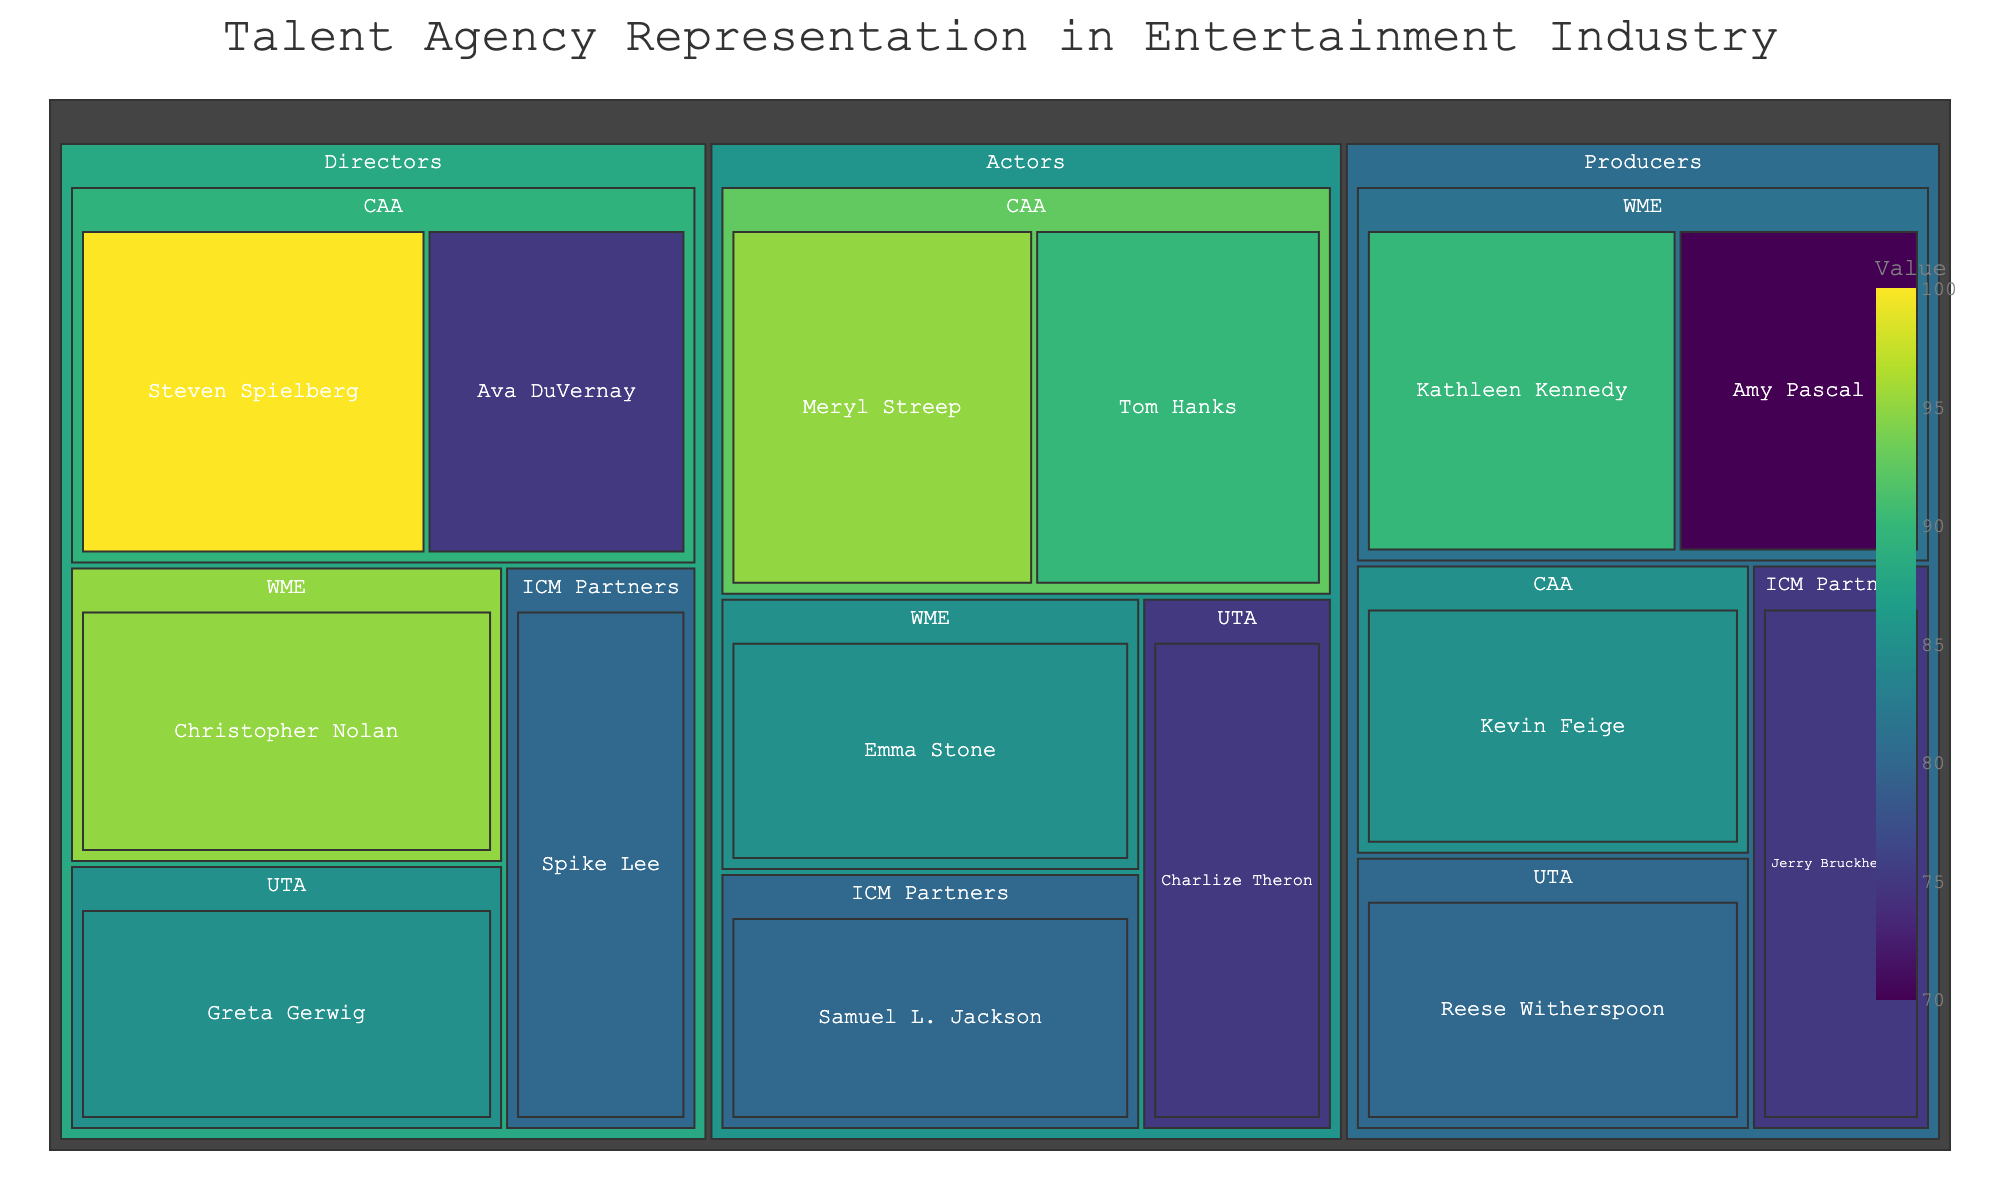What's the title of the Treemap? The title is usually prominently displayed at the top of the plot in a larger font size.
Answer: "Talent Agency Representation in Entertainment Industry" Which actor represented by ICM Partners is shown on the Treemap? ICM Partners has one actor listed, whose name appears within the "Actors" and "ICM Partners" nodes.
Answer: Samuel L. Jackson How many total talents does WME represent? By counting all the talents under the "WME" node across all categories, you can see that WME represents Emma Stone, Christopher Nolan, Kathleen Kennedy, and Amy Pascal.
Answer: 4 What is the combined value for talents represented by UTA in the "Actors" and "Directors" categories? UTA has two talents in these categories: Charlize Theron (75) and Greta Gerwig (85). Adding these values gives 75 + 85.
Answer: 160 Who is the director with the highest value, and which agency do they belong to? By looking under the "Directors" category, the highest value is found under Steven Spielberg, who is represented by CAA.
Answer: Steven Spielberg, CAA Which agency has the most representation in the "Producers" category? By looking at the number of boxes under the "Producers" category, WME represents two talents while others have fewer.
Answer: WME How do the values of actors represented by CAA compare to those represented by WME? The sum of values for CAA actors is Meryl Streep (95) + Tom Hanks (90) = 185, and for WME, it's just Emma Stone (85).
Answer: CAA has higher values What percentage of the collective talent value for directors does Christopher Nolan represent? Christopher Nolan represents 95 and the total value for all directors is 100 + 95 + 85 + 80 + 75 = 435. The percentage is (95/435) * 100.
Answer: ~21.84% How does the representation value of Reese Witherspoon compare to Kevin Feige in the "Producers" category? Reese Witherspoon's value is 80 and Kevin Feige's is 85; thus, Reese Witherspoon's value is 5 units less than Kevin Feige's.
Answer: Reese Witherspoon's value is 5 less Is there any agency that has equal representation in all categories? By considering each category: CAA has representation in all categories but not equal amounts, so do the other agencies. Therefore, no agency has exactly equal representation across all categories.
Answer: No 